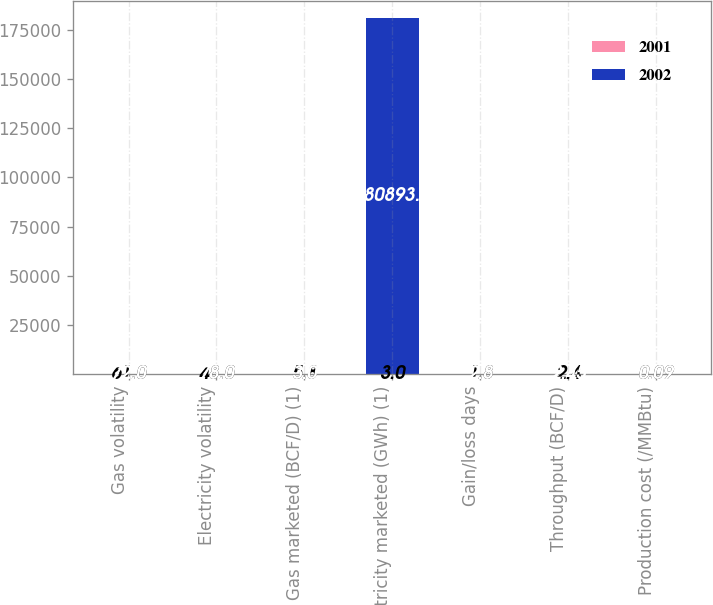<chart> <loc_0><loc_0><loc_500><loc_500><stacked_bar_chart><ecel><fcel>Gas volatility<fcel>Electricity volatility<fcel>Gas marketed (BCF/D) (1)<fcel>Electricity marketed (GWh) (1)<fcel>Gain/loss days<fcel>Throughput (BCF/D)<fcel>Production cost (/MMBtu)<nl><fcel>2001<fcel>61<fcel>48<fcel>5.8<fcel>3<fcel>1.8<fcel>2.4<fcel>0.09<nl><fcel>2002<fcel>72<fcel>78<fcel>3<fcel>180893<fcel>2.8<fcel>2.45<fcel>0.09<nl></chart> 